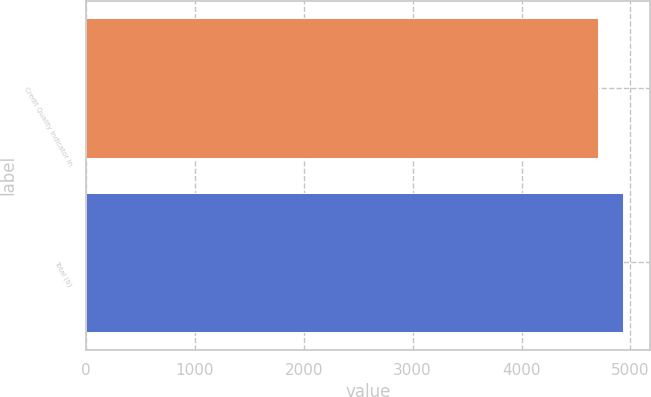<chart> <loc_0><loc_0><loc_500><loc_500><bar_chart><fcel>Credit Quality Indicator In<fcel>Total (b)<nl><fcel>4698<fcel>4935<nl></chart> 